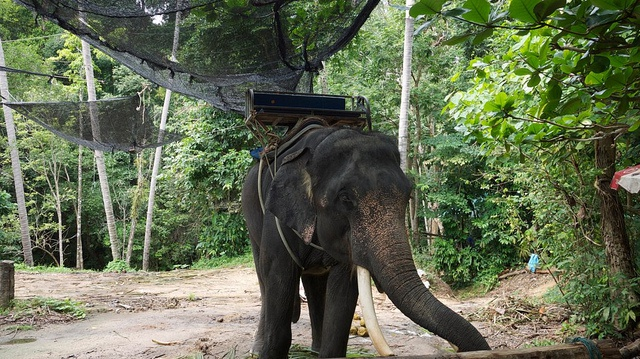Describe the objects in this image and their specific colors. I can see elephant in olive, black, and gray tones and bench in olive, black, gray, darkgreen, and darkgray tones in this image. 